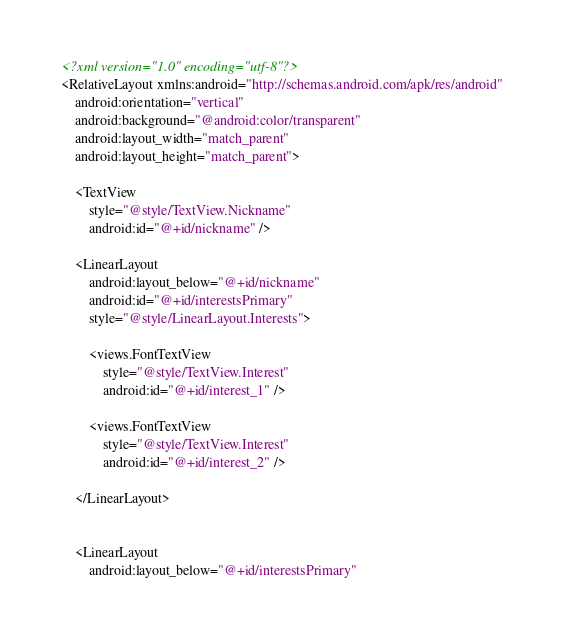<code> <loc_0><loc_0><loc_500><loc_500><_XML_><?xml version="1.0" encoding="utf-8"?>
<RelativeLayout xmlns:android="http://schemas.android.com/apk/res/android"
    android:orientation="vertical"
    android:background="@android:color/transparent"
    android:layout_width="match_parent"
    android:layout_height="match_parent">

    <TextView
        style="@style/TextView.Nickname"
        android:id="@+id/nickname" />

    <LinearLayout
        android:layout_below="@+id/nickname"
        android:id="@+id/interestsPrimary"
        style="@style/LinearLayout.Interests">

        <views.FontTextView
            style="@style/TextView.Interest"
            android:id="@+id/interest_1" />

        <views.FontTextView
            style="@style/TextView.Interest"
            android:id="@+id/interest_2" />

    </LinearLayout>


    <LinearLayout
        android:layout_below="@+id/interestsPrimary"</code> 